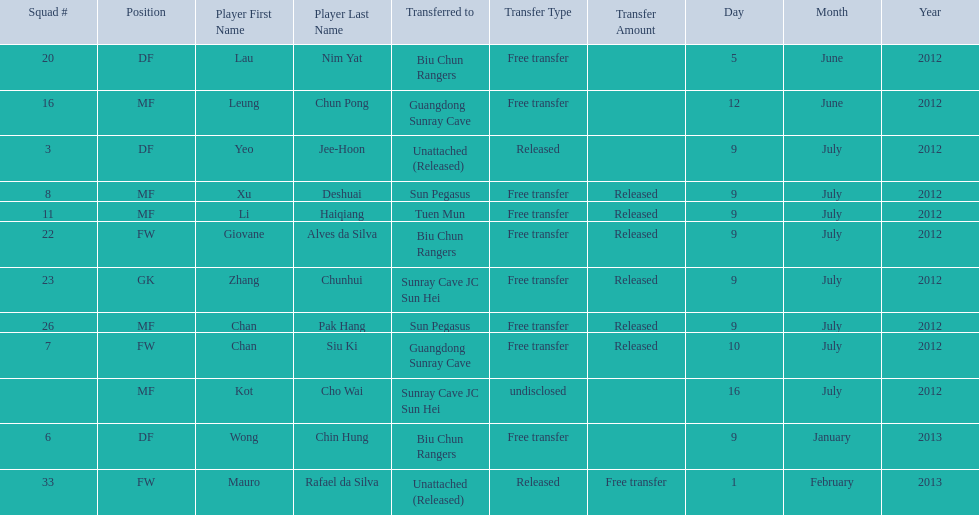Which players are listed? Lau Nim Yat, Leung Chun Pong, Yeo Jee-Hoon, Xu Deshuai, Li Haiqiang, Giovane Alves da Silva, Zhang Chunhui, Chan Pak Hang, Chan Siu Ki, Kot Cho Wai, Wong Chin Hung, Mauro Rafael da Silva. Which dates were players transferred to the biu chun rangers? 5 June 2012, 9 July 2012, 9 January 2013. Of those which is the date for wong chin hung? 9 January 2013. 